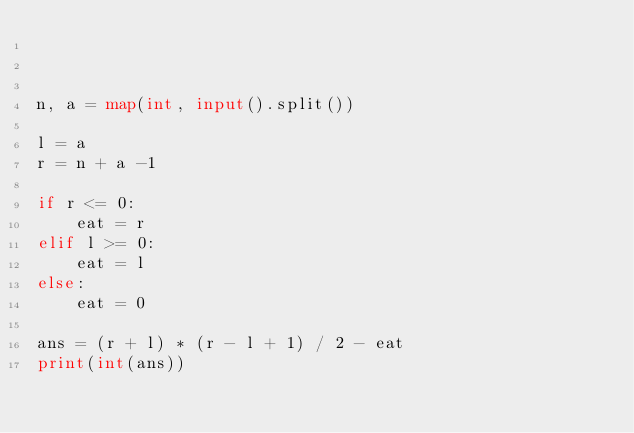Convert code to text. <code><loc_0><loc_0><loc_500><loc_500><_Python_>


n, a = map(int, input().split())

l = a
r = n + a -1

if r <= 0:
    eat = r
elif l >= 0:
    eat = l
else:
    eat = 0

ans = (r + l) * (r - l + 1) / 2 - eat
print(int(ans))


</code> 